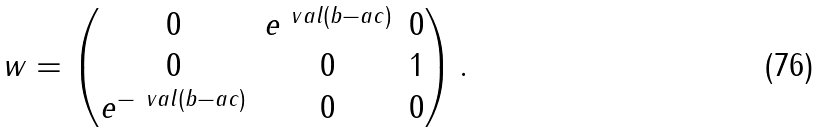<formula> <loc_0><loc_0><loc_500><loc_500>\ w = \begin{pmatrix} 0 & e ^ { \ v a l ( b - a c ) } & 0 \\ 0 & 0 & 1 \\ e ^ { - \ v a l ( b - a c ) } & 0 & 0 \end{pmatrix} .</formula> 